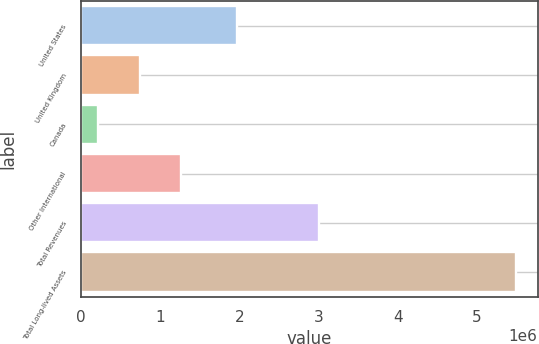Convert chart. <chart><loc_0><loc_0><loc_500><loc_500><bar_chart><fcel>United States<fcel>United Kingdom<fcel>Canada<fcel>Other International<fcel>Total Revenues<fcel>Total Long-lived Assets<nl><fcel>1.97387e+06<fcel>742976<fcel>215232<fcel>1.27072e+06<fcel>3.00798e+06<fcel>5.49268e+06<nl></chart> 